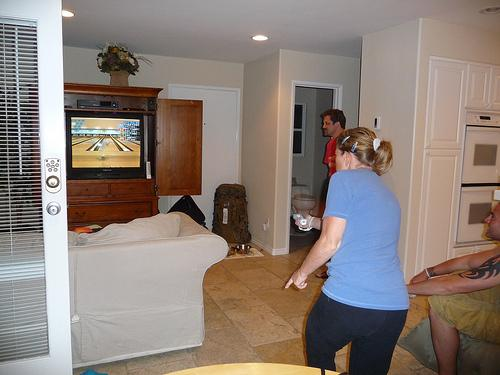Incorporate the man's attire in the description of the scene. A woman in a blue shirt plays wii, with a man in a red shirt behind her, both looking at the television. Describe the location of the basket of flowers in the image. There's a basket of flowers placed on top of the television stand. Write about the ongoing activity along with the person's attire. The woman in a blue top with blonde hair tied in a white scrunchie is playing wii and looking at the television. Explain the setup of the room witnessed in the image. A room with a television in a large wooden stand surrounded by a tan couch, white couch, and ceramic tile floor. What kind of game is being shown on the television screen? There is a bowling alley displayed on the television screen. Enumerate the key items in the room where the scene is taking place. A television in a wooden stand, a basket of flowers, a white couch, a white toilet, tan couch, and ceramic tile floor are present. Detail the appearance of the woman playing the game. A blonde woman in a light blue shirt with her hair in a ponytail secured by a white scrunchie. Briefly mention the primary action happening in the picture and the person involved in it. A woman holding a wii controller is playing a game and looking at the television. Mention the other person in the scene and a distinctive feature. There's a man behind the woman sporting a green tattoo on his arm. Describe the hair accessories of the central character. The woman has a white scrunchie and barretts in her hair. 